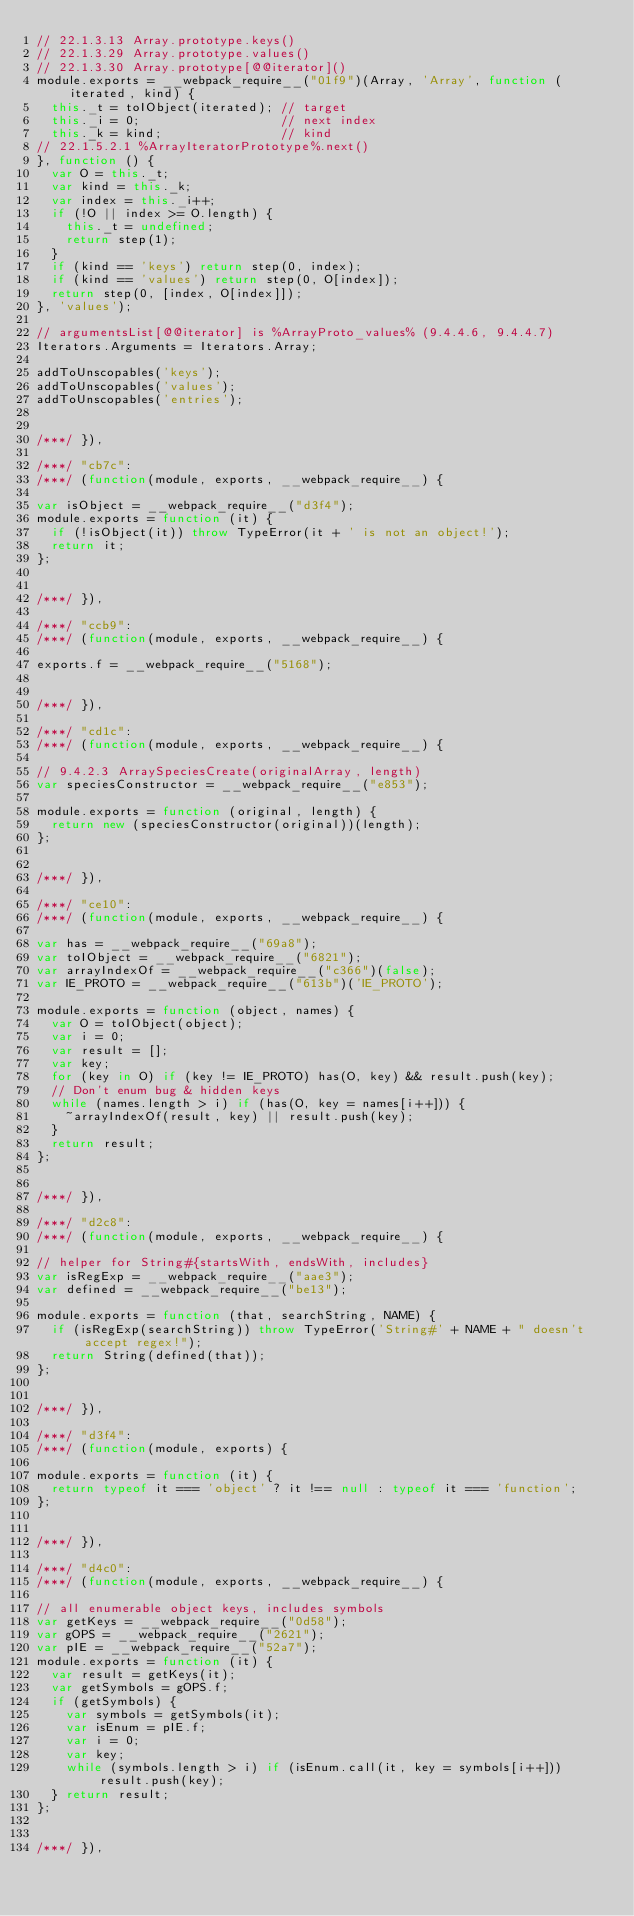Convert code to text. <code><loc_0><loc_0><loc_500><loc_500><_JavaScript_>// 22.1.3.13 Array.prototype.keys()
// 22.1.3.29 Array.prototype.values()
// 22.1.3.30 Array.prototype[@@iterator]()
module.exports = __webpack_require__("01f9")(Array, 'Array', function (iterated, kind) {
  this._t = toIObject(iterated); // target
  this._i = 0;                   // next index
  this._k = kind;                // kind
// 22.1.5.2.1 %ArrayIteratorPrototype%.next()
}, function () {
  var O = this._t;
  var kind = this._k;
  var index = this._i++;
  if (!O || index >= O.length) {
    this._t = undefined;
    return step(1);
  }
  if (kind == 'keys') return step(0, index);
  if (kind == 'values') return step(0, O[index]);
  return step(0, [index, O[index]]);
}, 'values');

// argumentsList[@@iterator] is %ArrayProto_values% (9.4.4.6, 9.4.4.7)
Iterators.Arguments = Iterators.Array;

addToUnscopables('keys');
addToUnscopables('values');
addToUnscopables('entries');


/***/ }),

/***/ "cb7c":
/***/ (function(module, exports, __webpack_require__) {

var isObject = __webpack_require__("d3f4");
module.exports = function (it) {
  if (!isObject(it)) throw TypeError(it + ' is not an object!');
  return it;
};


/***/ }),

/***/ "ccb9":
/***/ (function(module, exports, __webpack_require__) {

exports.f = __webpack_require__("5168");


/***/ }),

/***/ "cd1c":
/***/ (function(module, exports, __webpack_require__) {

// 9.4.2.3 ArraySpeciesCreate(originalArray, length)
var speciesConstructor = __webpack_require__("e853");

module.exports = function (original, length) {
  return new (speciesConstructor(original))(length);
};


/***/ }),

/***/ "ce10":
/***/ (function(module, exports, __webpack_require__) {

var has = __webpack_require__("69a8");
var toIObject = __webpack_require__("6821");
var arrayIndexOf = __webpack_require__("c366")(false);
var IE_PROTO = __webpack_require__("613b")('IE_PROTO');

module.exports = function (object, names) {
  var O = toIObject(object);
  var i = 0;
  var result = [];
  var key;
  for (key in O) if (key != IE_PROTO) has(O, key) && result.push(key);
  // Don't enum bug & hidden keys
  while (names.length > i) if (has(O, key = names[i++])) {
    ~arrayIndexOf(result, key) || result.push(key);
  }
  return result;
};


/***/ }),

/***/ "d2c8":
/***/ (function(module, exports, __webpack_require__) {

// helper for String#{startsWith, endsWith, includes}
var isRegExp = __webpack_require__("aae3");
var defined = __webpack_require__("be13");

module.exports = function (that, searchString, NAME) {
  if (isRegExp(searchString)) throw TypeError('String#' + NAME + " doesn't accept regex!");
  return String(defined(that));
};


/***/ }),

/***/ "d3f4":
/***/ (function(module, exports) {

module.exports = function (it) {
  return typeof it === 'object' ? it !== null : typeof it === 'function';
};


/***/ }),

/***/ "d4c0":
/***/ (function(module, exports, __webpack_require__) {

// all enumerable object keys, includes symbols
var getKeys = __webpack_require__("0d58");
var gOPS = __webpack_require__("2621");
var pIE = __webpack_require__("52a7");
module.exports = function (it) {
  var result = getKeys(it);
  var getSymbols = gOPS.f;
  if (getSymbols) {
    var symbols = getSymbols(it);
    var isEnum = pIE.f;
    var i = 0;
    var key;
    while (symbols.length > i) if (isEnum.call(it, key = symbols[i++])) result.push(key);
  } return result;
};


/***/ }),
</code> 